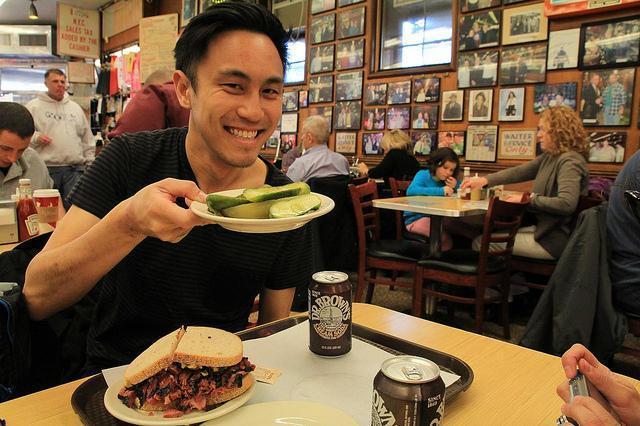How many chairs can you see?
Give a very brief answer. 2. How many people are there?
Give a very brief answer. 8. How many dining tables are in the picture?
Give a very brief answer. 2. How many keyboards are on the desk?
Give a very brief answer. 0. 